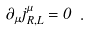Convert formula to latex. <formula><loc_0><loc_0><loc_500><loc_500>\partial _ { \mu } j ^ { \mu } _ { R , L } = 0 \ .</formula> 